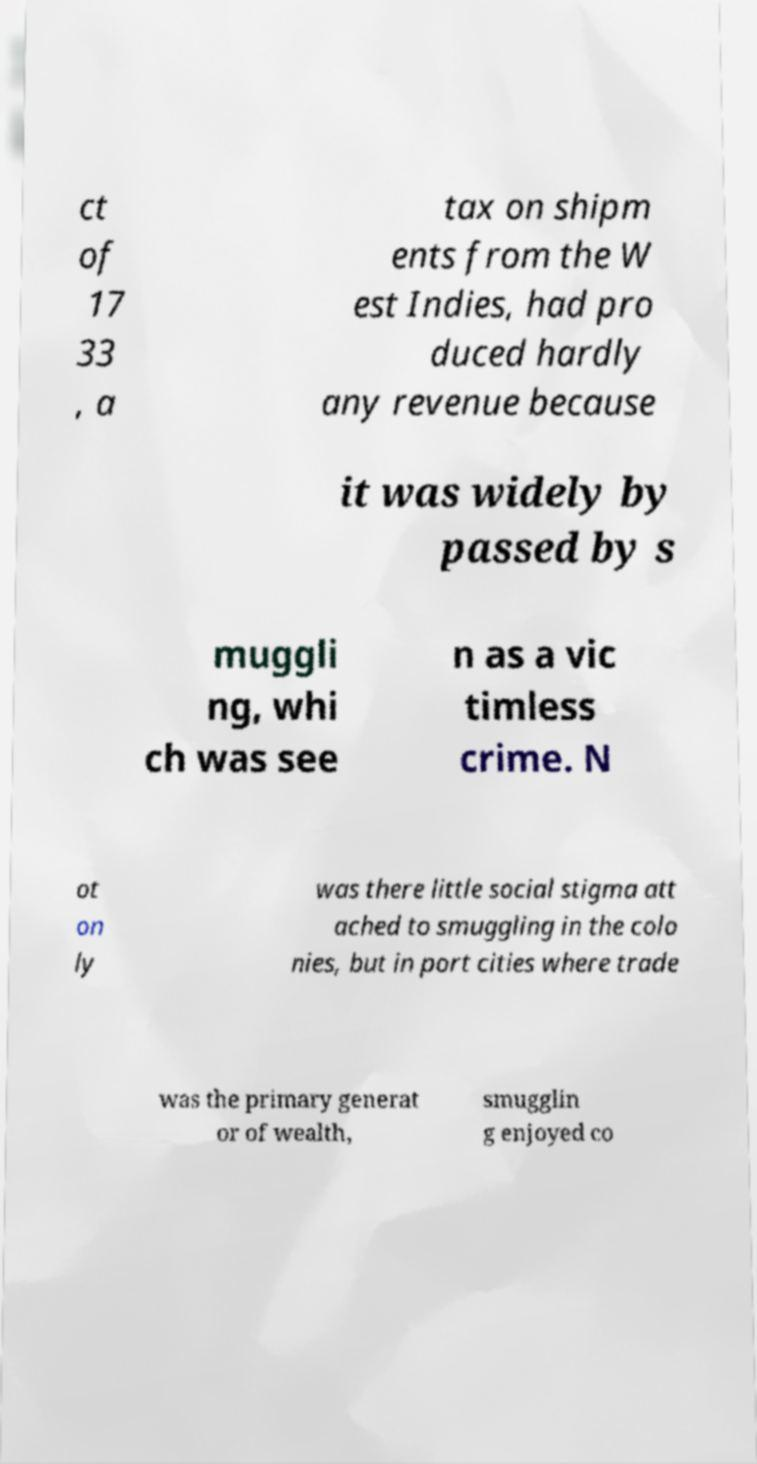I need the written content from this picture converted into text. Can you do that? ct of 17 33 , a tax on shipm ents from the W est Indies, had pro duced hardly any revenue because it was widely by passed by s muggli ng, whi ch was see n as a vic timless crime. N ot on ly was there little social stigma att ached to smuggling in the colo nies, but in port cities where trade was the primary generat or of wealth, smugglin g enjoyed co 